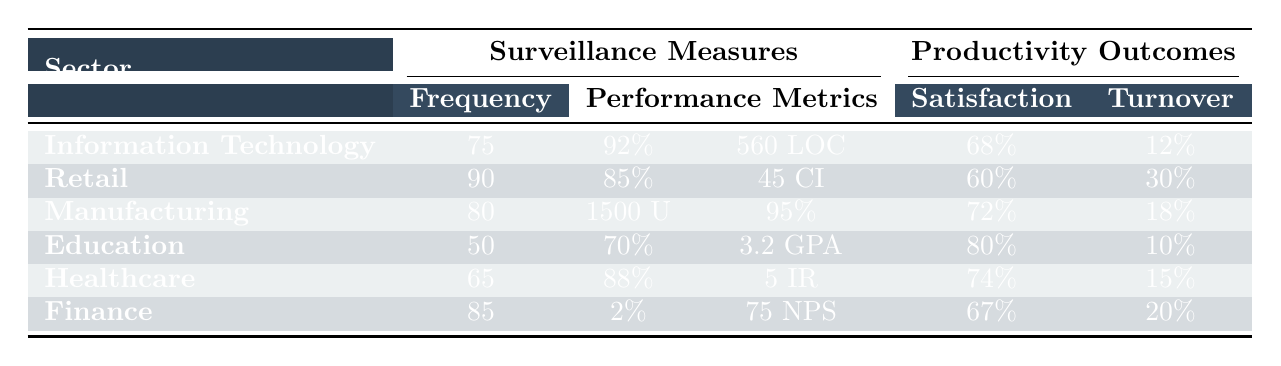What is the highest frequency of monitoring among the sectors? By looking at the "Frequency" column for each sector, the highest value is 90, which corresponds to the Retail sector.
Answer: 90 What percentage of employee satisfaction does the Education sector report? The Education sector reports an employee satisfaction percentage which is listed under the "Satisfaction" column as 80%.
Answer: 80% Which sector has the lowest turnover rate? Comparing the "Turnover" rates across sectors, the Education sector has the lowest rate at 10%.
Answer: Education What is the average turnover rate of all sectors? To find the average turnover rate, sum the turnover rates from all sectors (12 + 30 + 18 + 10 + 15 + 20 = 105) and divide by the number of sectors (6). The average is 105/6 = 17.5%.
Answer: 17.5% Are the employee satisfaction rates in Information Technology and Healthcare sectors both above 70%? The employee satisfaction rate for Information Technology is 68%, while for Healthcare, it is 74%. Since 68% is not above 70%, the statement is false.
Answer: No Which sector has a higher task completion rate: Information Technology or Retail? Information Technology has a task completion rate of 92%, while Retail has 85%. Since 92% is greater than 85%, Information Technology has a higher rate.
Answer: Information Technology What is the difference in production output between the Manufacturing and Retail sectors? The production output for Manufacturing is listed as 1500 units per shift, while Retail does not specify production output; instead, it specifies sales targets. Thus, we can't calculate a difference in production output.
Answer: Not applicable How does the employee satisfaction in the Healthcare sector compare to that in Finance? Employee satisfaction in Healthcare is 74%, while in Finance it is 67%. 74% is higher than 67%, indicating that employees in Healthcare are more satisfied than those in Finance.
Answer: Healthcare What is the best average GPA reported in the sectors? The Education sector reports an average GPA of 3.2. Since it is the only sector reporting GPA, it represents the best average.
Answer: 3.2 If the frequency of monitoring in the Retail sector were to be reduced by 10%, what would the new frequency be? The Retail sector currently shows a frequency of 90. Reducing this by 10% gives 90 - (10% of 90) = 90 - 9 = 81.
Answer: 81 